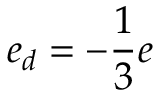Convert formula to latex. <formula><loc_0><loc_0><loc_500><loc_500>e _ { d } = - \frac { 1 } { 3 } e</formula> 